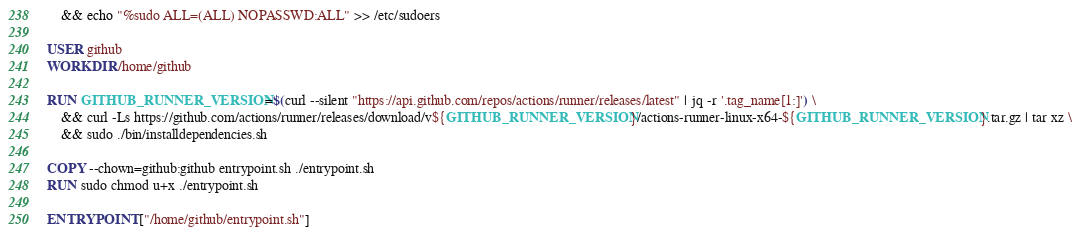<code> <loc_0><loc_0><loc_500><loc_500><_Dockerfile_>    && echo "%sudo ALL=(ALL) NOPASSWD:ALL" >> /etc/sudoers

USER github
WORKDIR /home/github

RUN GITHUB_RUNNER_VERSION=$(curl --silent "https://api.github.com/repos/actions/runner/releases/latest" | jq -r '.tag_name[1:]') \
    && curl -Ls https://github.com/actions/runner/releases/download/v${GITHUB_RUNNER_VERSION}/actions-runner-linux-x64-${GITHUB_RUNNER_VERSION}.tar.gz | tar xz \
    && sudo ./bin/installdependencies.sh

COPY --chown=github:github entrypoint.sh ./entrypoint.sh
RUN sudo chmod u+x ./entrypoint.sh

ENTRYPOINT ["/home/github/entrypoint.sh"]
</code> 